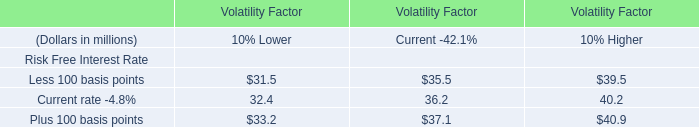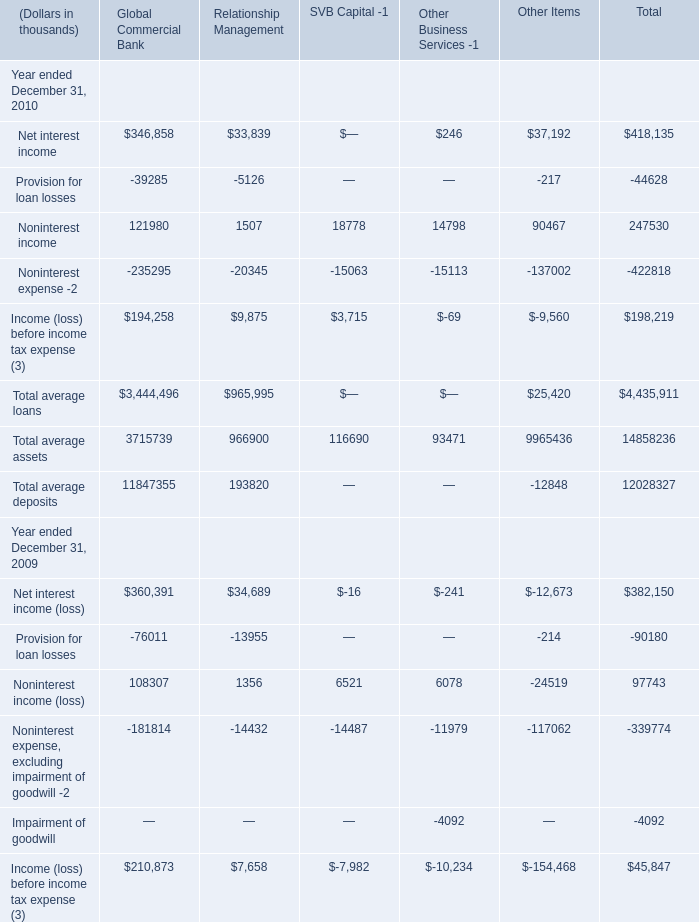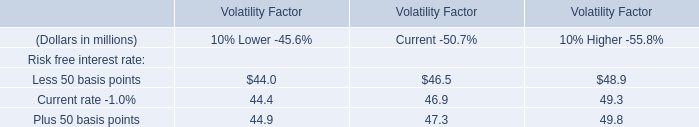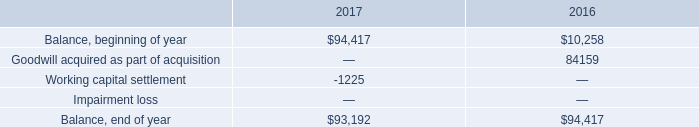What is the sum of the Income (loss) before income tax expense in 2010 for Total in the years where Noninterest income for Total is greater than 90000? (in thousand) 
Computations: (198219 + 45847)
Answer: 244066.0. 